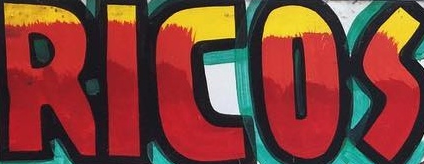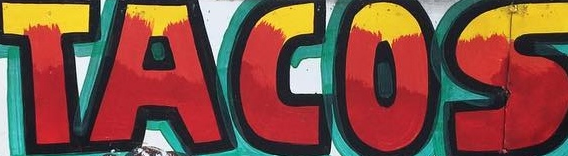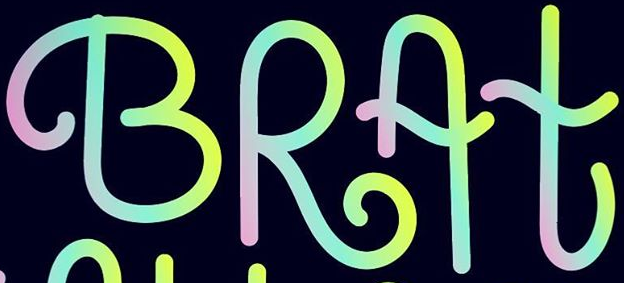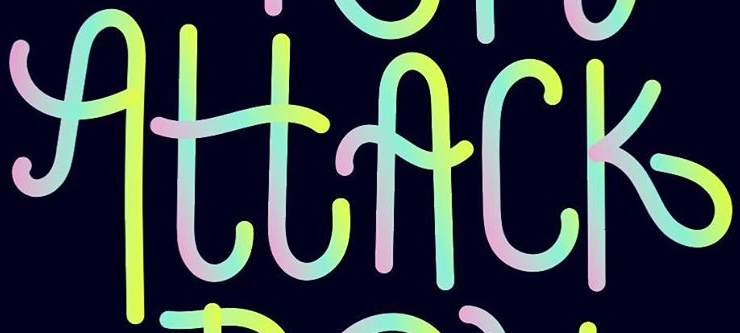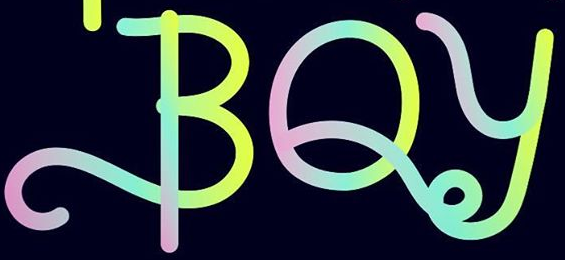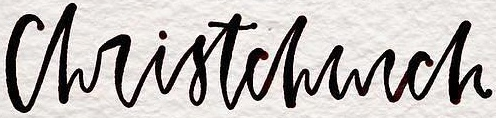What words can you see in these images in sequence, separated by a semicolon? RICOS; TACOS; BRAt; AttAck; BOy; christchurch 